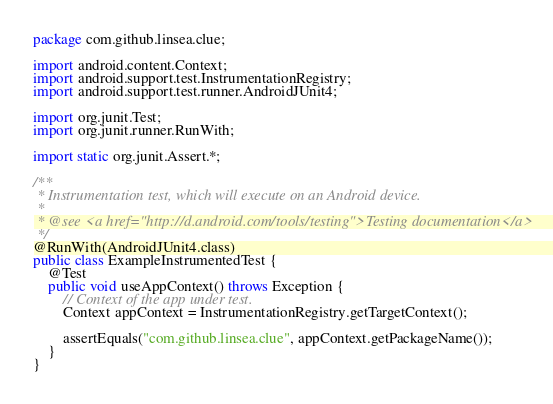<code> <loc_0><loc_0><loc_500><loc_500><_Java_>package com.github.linsea.clue;

import android.content.Context;
import android.support.test.InstrumentationRegistry;
import android.support.test.runner.AndroidJUnit4;

import org.junit.Test;
import org.junit.runner.RunWith;

import static org.junit.Assert.*;

/**
 * Instrumentation test, which will execute on an Android device.
 *
 * @see <a href="http://d.android.com/tools/testing">Testing documentation</a>
 */
@RunWith(AndroidJUnit4.class)
public class ExampleInstrumentedTest {
    @Test
    public void useAppContext() throws Exception {
        // Context of the app under test.
        Context appContext = InstrumentationRegistry.getTargetContext();

        assertEquals("com.github.linsea.clue", appContext.getPackageName());
    }
}
</code> 